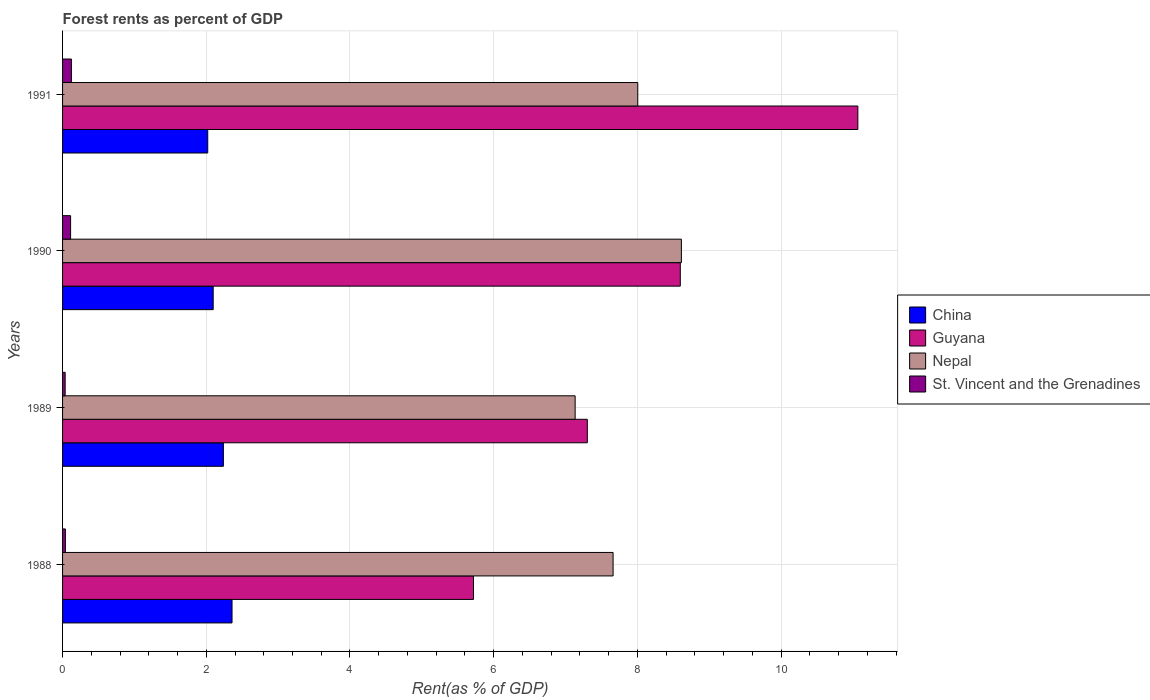How many groups of bars are there?
Offer a terse response. 4. Are the number of bars on each tick of the Y-axis equal?
Provide a succinct answer. Yes. How many bars are there on the 4th tick from the top?
Your response must be concise. 4. How many bars are there on the 4th tick from the bottom?
Your answer should be very brief. 4. What is the label of the 4th group of bars from the top?
Offer a terse response. 1988. In how many cases, is the number of bars for a given year not equal to the number of legend labels?
Offer a very short reply. 0. What is the forest rent in St. Vincent and the Grenadines in 1990?
Provide a short and direct response. 0.11. Across all years, what is the maximum forest rent in Guyana?
Offer a terse response. 11.07. Across all years, what is the minimum forest rent in St. Vincent and the Grenadines?
Your answer should be very brief. 0.04. In which year was the forest rent in China maximum?
Give a very brief answer. 1988. In which year was the forest rent in China minimum?
Provide a short and direct response. 1991. What is the total forest rent in Nepal in the graph?
Your answer should be very brief. 31.41. What is the difference between the forest rent in Guyana in 1989 and that in 1990?
Make the answer very short. -1.29. What is the difference between the forest rent in St. Vincent and the Grenadines in 1988 and the forest rent in China in 1989?
Provide a short and direct response. -2.2. What is the average forest rent in St. Vincent and the Grenadines per year?
Provide a succinct answer. 0.08. In the year 1988, what is the difference between the forest rent in China and forest rent in Guyana?
Provide a succinct answer. -3.36. What is the ratio of the forest rent in Nepal in 1989 to that in 1990?
Your response must be concise. 0.83. Is the forest rent in China in 1988 less than that in 1990?
Keep it short and to the point. No. Is the difference between the forest rent in China in 1990 and 1991 greater than the difference between the forest rent in Guyana in 1990 and 1991?
Provide a succinct answer. Yes. What is the difference between the highest and the second highest forest rent in Nepal?
Your response must be concise. 0.61. What is the difference between the highest and the lowest forest rent in St. Vincent and the Grenadines?
Your response must be concise. 0.09. Is the sum of the forest rent in Nepal in 1989 and 1991 greater than the maximum forest rent in China across all years?
Offer a terse response. Yes. What does the 2nd bar from the top in 1988 represents?
Give a very brief answer. Nepal. What does the 2nd bar from the bottom in 1988 represents?
Provide a short and direct response. Guyana. Is it the case that in every year, the sum of the forest rent in Nepal and forest rent in China is greater than the forest rent in St. Vincent and the Grenadines?
Provide a succinct answer. Yes. How many bars are there?
Provide a short and direct response. 16. Are the values on the major ticks of X-axis written in scientific E-notation?
Keep it short and to the point. No. Does the graph contain grids?
Make the answer very short. Yes. How many legend labels are there?
Ensure brevity in your answer.  4. How are the legend labels stacked?
Your answer should be very brief. Vertical. What is the title of the graph?
Your response must be concise. Forest rents as percent of GDP. What is the label or title of the X-axis?
Your answer should be very brief. Rent(as % of GDP). What is the Rent(as % of GDP) of China in 1988?
Your response must be concise. 2.36. What is the Rent(as % of GDP) in Guyana in 1988?
Your answer should be compact. 5.72. What is the Rent(as % of GDP) of Nepal in 1988?
Provide a succinct answer. 7.66. What is the Rent(as % of GDP) in St. Vincent and the Grenadines in 1988?
Give a very brief answer. 0.04. What is the Rent(as % of GDP) in China in 1989?
Keep it short and to the point. 2.24. What is the Rent(as % of GDP) in Guyana in 1989?
Ensure brevity in your answer.  7.3. What is the Rent(as % of GDP) in Nepal in 1989?
Provide a short and direct response. 7.13. What is the Rent(as % of GDP) in St. Vincent and the Grenadines in 1989?
Offer a terse response. 0.04. What is the Rent(as % of GDP) of China in 1990?
Offer a terse response. 2.1. What is the Rent(as % of GDP) in Guyana in 1990?
Your response must be concise. 8.6. What is the Rent(as % of GDP) of Nepal in 1990?
Your answer should be very brief. 8.61. What is the Rent(as % of GDP) of St. Vincent and the Grenadines in 1990?
Your answer should be compact. 0.11. What is the Rent(as % of GDP) of China in 1991?
Provide a succinct answer. 2.02. What is the Rent(as % of GDP) of Guyana in 1991?
Your response must be concise. 11.07. What is the Rent(as % of GDP) of Nepal in 1991?
Your response must be concise. 8.01. What is the Rent(as % of GDP) in St. Vincent and the Grenadines in 1991?
Keep it short and to the point. 0.12. Across all years, what is the maximum Rent(as % of GDP) of China?
Offer a terse response. 2.36. Across all years, what is the maximum Rent(as % of GDP) of Guyana?
Offer a terse response. 11.07. Across all years, what is the maximum Rent(as % of GDP) in Nepal?
Offer a very short reply. 8.61. Across all years, what is the maximum Rent(as % of GDP) of St. Vincent and the Grenadines?
Your response must be concise. 0.12. Across all years, what is the minimum Rent(as % of GDP) of China?
Provide a succinct answer. 2.02. Across all years, what is the minimum Rent(as % of GDP) of Guyana?
Offer a very short reply. 5.72. Across all years, what is the minimum Rent(as % of GDP) in Nepal?
Your answer should be compact. 7.13. Across all years, what is the minimum Rent(as % of GDP) of St. Vincent and the Grenadines?
Provide a succinct answer. 0.04. What is the total Rent(as % of GDP) in China in the graph?
Keep it short and to the point. 8.71. What is the total Rent(as % of GDP) of Guyana in the graph?
Your answer should be very brief. 32.69. What is the total Rent(as % of GDP) in Nepal in the graph?
Your response must be concise. 31.41. What is the total Rent(as % of GDP) in St. Vincent and the Grenadines in the graph?
Offer a very short reply. 0.31. What is the difference between the Rent(as % of GDP) of China in 1988 and that in 1989?
Your answer should be compact. 0.12. What is the difference between the Rent(as % of GDP) in Guyana in 1988 and that in 1989?
Keep it short and to the point. -1.58. What is the difference between the Rent(as % of GDP) of Nepal in 1988 and that in 1989?
Offer a very short reply. 0.53. What is the difference between the Rent(as % of GDP) of St. Vincent and the Grenadines in 1988 and that in 1989?
Provide a succinct answer. 0. What is the difference between the Rent(as % of GDP) in China in 1988 and that in 1990?
Provide a short and direct response. 0.26. What is the difference between the Rent(as % of GDP) of Guyana in 1988 and that in 1990?
Your answer should be compact. -2.88. What is the difference between the Rent(as % of GDP) of Nepal in 1988 and that in 1990?
Your response must be concise. -0.95. What is the difference between the Rent(as % of GDP) in St. Vincent and the Grenadines in 1988 and that in 1990?
Your answer should be very brief. -0.07. What is the difference between the Rent(as % of GDP) in China in 1988 and that in 1991?
Give a very brief answer. 0.34. What is the difference between the Rent(as % of GDP) of Guyana in 1988 and that in 1991?
Ensure brevity in your answer.  -5.35. What is the difference between the Rent(as % of GDP) in Nepal in 1988 and that in 1991?
Your answer should be very brief. -0.34. What is the difference between the Rent(as % of GDP) in St. Vincent and the Grenadines in 1988 and that in 1991?
Your response must be concise. -0.08. What is the difference between the Rent(as % of GDP) in China in 1989 and that in 1990?
Your answer should be very brief. 0.14. What is the difference between the Rent(as % of GDP) of Guyana in 1989 and that in 1990?
Your answer should be compact. -1.29. What is the difference between the Rent(as % of GDP) in Nepal in 1989 and that in 1990?
Your answer should be very brief. -1.48. What is the difference between the Rent(as % of GDP) of St. Vincent and the Grenadines in 1989 and that in 1990?
Provide a short and direct response. -0.08. What is the difference between the Rent(as % of GDP) of China in 1989 and that in 1991?
Provide a succinct answer. 0.22. What is the difference between the Rent(as % of GDP) in Guyana in 1989 and that in 1991?
Your answer should be very brief. -3.77. What is the difference between the Rent(as % of GDP) in Nepal in 1989 and that in 1991?
Make the answer very short. -0.87. What is the difference between the Rent(as % of GDP) of St. Vincent and the Grenadines in 1989 and that in 1991?
Offer a very short reply. -0.09. What is the difference between the Rent(as % of GDP) of China in 1990 and that in 1991?
Offer a very short reply. 0.08. What is the difference between the Rent(as % of GDP) in Guyana in 1990 and that in 1991?
Provide a succinct answer. -2.47. What is the difference between the Rent(as % of GDP) of Nepal in 1990 and that in 1991?
Provide a short and direct response. 0.61. What is the difference between the Rent(as % of GDP) of St. Vincent and the Grenadines in 1990 and that in 1991?
Offer a terse response. -0.01. What is the difference between the Rent(as % of GDP) of China in 1988 and the Rent(as % of GDP) of Guyana in 1989?
Make the answer very short. -4.94. What is the difference between the Rent(as % of GDP) in China in 1988 and the Rent(as % of GDP) in Nepal in 1989?
Make the answer very short. -4.78. What is the difference between the Rent(as % of GDP) in China in 1988 and the Rent(as % of GDP) in St. Vincent and the Grenadines in 1989?
Your answer should be very brief. 2.32. What is the difference between the Rent(as % of GDP) in Guyana in 1988 and the Rent(as % of GDP) in Nepal in 1989?
Offer a very short reply. -1.41. What is the difference between the Rent(as % of GDP) in Guyana in 1988 and the Rent(as % of GDP) in St. Vincent and the Grenadines in 1989?
Your response must be concise. 5.68. What is the difference between the Rent(as % of GDP) of Nepal in 1988 and the Rent(as % of GDP) of St. Vincent and the Grenadines in 1989?
Offer a very short reply. 7.63. What is the difference between the Rent(as % of GDP) of China in 1988 and the Rent(as % of GDP) of Guyana in 1990?
Your answer should be very brief. -6.24. What is the difference between the Rent(as % of GDP) in China in 1988 and the Rent(as % of GDP) in Nepal in 1990?
Your response must be concise. -6.25. What is the difference between the Rent(as % of GDP) of China in 1988 and the Rent(as % of GDP) of St. Vincent and the Grenadines in 1990?
Provide a short and direct response. 2.25. What is the difference between the Rent(as % of GDP) of Guyana in 1988 and the Rent(as % of GDP) of Nepal in 1990?
Make the answer very short. -2.89. What is the difference between the Rent(as % of GDP) in Guyana in 1988 and the Rent(as % of GDP) in St. Vincent and the Grenadines in 1990?
Provide a succinct answer. 5.61. What is the difference between the Rent(as % of GDP) of Nepal in 1988 and the Rent(as % of GDP) of St. Vincent and the Grenadines in 1990?
Give a very brief answer. 7.55. What is the difference between the Rent(as % of GDP) in China in 1988 and the Rent(as % of GDP) in Guyana in 1991?
Keep it short and to the point. -8.71. What is the difference between the Rent(as % of GDP) of China in 1988 and the Rent(as % of GDP) of Nepal in 1991?
Your answer should be compact. -5.65. What is the difference between the Rent(as % of GDP) of China in 1988 and the Rent(as % of GDP) of St. Vincent and the Grenadines in 1991?
Make the answer very short. 2.24. What is the difference between the Rent(as % of GDP) in Guyana in 1988 and the Rent(as % of GDP) in Nepal in 1991?
Give a very brief answer. -2.29. What is the difference between the Rent(as % of GDP) of Guyana in 1988 and the Rent(as % of GDP) of St. Vincent and the Grenadines in 1991?
Ensure brevity in your answer.  5.6. What is the difference between the Rent(as % of GDP) of Nepal in 1988 and the Rent(as % of GDP) of St. Vincent and the Grenadines in 1991?
Keep it short and to the point. 7.54. What is the difference between the Rent(as % of GDP) in China in 1989 and the Rent(as % of GDP) in Guyana in 1990?
Your answer should be very brief. -6.36. What is the difference between the Rent(as % of GDP) of China in 1989 and the Rent(as % of GDP) of Nepal in 1990?
Your response must be concise. -6.37. What is the difference between the Rent(as % of GDP) of China in 1989 and the Rent(as % of GDP) of St. Vincent and the Grenadines in 1990?
Keep it short and to the point. 2.13. What is the difference between the Rent(as % of GDP) in Guyana in 1989 and the Rent(as % of GDP) in Nepal in 1990?
Provide a short and direct response. -1.31. What is the difference between the Rent(as % of GDP) in Guyana in 1989 and the Rent(as % of GDP) in St. Vincent and the Grenadines in 1990?
Ensure brevity in your answer.  7.19. What is the difference between the Rent(as % of GDP) in Nepal in 1989 and the Rent(as % of GDP) in St. Vincent and the Grenadines in 1990?
Give a very brief answer. 7.02. What is the difference between the Rent(as % of GDP) of China in 1989 and the Rent(as % of GDP) of Guyana in 1991?
Provide a succinct answer. -8.83. What is the difference between the Rent(as % of GDP) of China in 1989 and the Rent(as % of GDP) of Nepal in 1991?
Your response must be concise. -5.77. What is the difference between the Rent(as % of GDP) of China in 1989 and the Rent(as % of GDP) of St. Vincent and the Grenadines in 1991?
Give a very brief answer. 2.12. What is the difference between the Rent(as % of GDP) of Guyana in 1989 and the Rent(as % of GDP) of Nepal in 1991?
Provide a short and direct response. -0.7. What is the difference between the Rent(as % of GDP) in Guyana in 1989 and the Rent(as % of GDP) in St. Vincent and the Grenadines in 1991?
Give a very brief answer. 7.18. What is the difference between the Rent(as % of GDP) in Nepal in 1989 and the Rent(as % of GDP) in St. Vincent and the Grenadines in 1991?
Your answer should be very brief. 7.01. What is the difference between the Rent(as % of GDP) of China in 1990 and the Rent(as % of GDP) of Guyana in 1991?
Give a very brief answer. -8.97. What is the difference between the Rent(as % of GDP) in China in 1990 and the Rent(as % of GDP) in Nepal in 1991?
Offer a very short reply. -5.91. What is the difference between the Rent(as % of GDP) in China in 1990 and the Rent(as % of GDP) in St. Vincent and the Grenadines in 1991?
Give a very brief answer. 1.97. What is the difference between the Rent(as % of GDP) in Guyana in 1990 and the Rent(as % of GDP) in Nepal in 1991?
Your response must be concise. 0.59. What is the difference between the Rent(as % of GDP) of Guyana in 1990 and the Rent(as % of GDP) of St. Vincent and the Grenadines in 1991?
Provide a succinct answer. 8.47. What is the difference between the Rent(as % of GDP) in Nepal in 1990 and the Rent(as % of GDP) in St. Vincent and the Grenadines in 1991?
Provide a succinct answer. 8.49. What is the average Rent(as % of GDP) in China per year?
Offer a very short reply. 2.18. What is the average Rent(as % of GDP) of Guyana per year?
Ensure brevity in your answer.  8.17. What is the average Rent(as % of GDP) of Nepal per year?
Keep it short and to the point. 7.85. What is the average Rent(as % of GDP) of St. Vincent and the Grenadines per year?
Your answer should be very brief. 0.08. In the year 1988, what is the difference between the Rent(as % of GDP) in China and Rent(as % of GDP) in Guyana?
Your response must be concise. -3.36. In the year 1988, what is the difference between the Rent(as % of GDP) in China and Rent(as % of GDP) in Nepal?
Make the answer very short. -5.3. In the year 1988, what is the difference between the Rent(as % of GDP) in China and Rent(as % of GDP) in St. Vincent and the Grenadines?
Offer a terse response. 2.32. In the year 1988, what is the difference between the Rent(as % of GDP) of Guyana and Rent(as % of GDP) of Nepal?
Offer a very short reply. -1.94. In the year 1988, what is the difference between the Rent(as % of GDP) of Guyana and Rent(as % of GDP) of St. Vincent and the Grenadines?
Provide a short and direct response. 5.68. In the year 1988, what is the difference between the Rent(as % of GDP) of Nepal and Rent(as % of GDP) of St. Vincent and the Grenadines?
Your answer should be very brief. 7.62. In the year 1989, what is the difference between the Rent(as % of GDP) of China and Rent(as % of GDP) of Guyana?
Provide a succinct answer. -5.07. In the year 1989, what is the difference between the Rent(as % of GDP) of China and Rent(as % of GDP) of Nepal?
Ensure brevity in your answer.  -4.9. In the year 1989, what is the difference between the Rent(as % of GDP) in China and Rent(as % of GDP) in St. Vincent and the Grenadines?
Offer a terse response. 2.2. In the year 1989, what is the difference between the Rent(as % of GDP) of Guyana and Rent(as % of GDP) of Nepal?
Make the answer very short. 0.17. In the year 1989, what is the difference between the Rent(as % of GDP) of Guyana and Rent(as % of GDP) of St. Vincent and the Grenadines?
Offer a very short reply. 7.27. In the year 1989, what is the difference between the Rent(as % of GDP) of Nepal and Rent(as % of GDP) of St. Vincent and the Grenadines?
Provide a succinct answer. 7.1. In the year 1990, what is the difference between the Rent(as % of GDP) in China and Rent(as % of GDP) in Guyana?
Your answer should be very brief. -6.5. In the year 1990, what is the difference between the Rent(as % of GDP) of China and Rent(as % of GDP) of Nepal?
Offer a very short reply. -6.52. In the year 1990, what is the difference between the Rent(as % of GDP) in China and Rent(as % of GDP) in St. Vincent and the Grenadines?
Your response must be concise. 1.98. In the year 1990, what is the difference between the Rent(as % of GDP) in Guyana and Rent(as % of GDP) in Nepal?
Give a very brief answer. -0.01. In the year 1990, what is the difference between the Rent(as % of GDP) of Guyana and Rent(as % of GDP) of St. Vincent and the Grenadines?
Your answer should be very brief. 8.49. In the year 1990, what is the difference between the Rent(as % of GDP) of Nepal and Rent(as % of GDP) of St. Vincent and the Grenadines?
Make the answer very short. 8.5. In the year 1991, what is the difference between the Rent(as % of GDP) in China and Rent(as % of GDP) in Guyana?
Your response must be concise. -9.05. In the year 1991, what is the difference between the Rent(as % of GDP) in China and Rent(as % of GDP) in Nepal?
Your response must be concise. -5.99. In the year 1991, what is the difference between the Rent(as % of GDP) in China and Rent(as % of GDP) in St. Vincent and the Grenadines?
Provide a short and direct response. 1.9. In the year 1991, what is the difference between the Rent(as % of GDP) of Guyana and Rent(as % of GDP) of Nepal?
Provide a short and direct response. 3.06. In the year 1991, what is the difference between the Rent(as % of GDP) in Guyana and Rent(as % of GDP) in St. Vincent and the Grenadines?
Your answer should be very brief. 10.95. In the year 1991, what is the difference between the Rent(as % of GDP) of Nepal and Rent(as % of GDP) of St. Vincent and the Grenadines?
Your answer should be very brief. 7.88. What is the ratio of the Rent(as % of GDP) in China in 1988 to that in 1989?
Your answer should be very brief. 1.05. What is the ratio of the Rent(as % of GDP) of Guyana in 1988 to that in 1989?
Ensure brevity in your answer.  0.78. What is the ratio of the Rent(as % of GDP) in Nepal in 1988 to that in 1989?
Make the answer very short. 1.07. What is the ratio of the Rent(as % of GDP) of St. Vincent and the Grenadines in 1988 to that in 1989?
Provide a succinct answer. 1.1. What is the ratio of the Rent(as % of GDP) in China in 1988 to that in 1990?
Your answer should be compact. 1.13. What is the ratio of the Rent(as % of GDP) of Guyana in 1988 to that in 1990?
Offer a terse response. 0.67. What is the ratio of the Rent(as % of GDP) of Nepal in 1988 to that in 1990?
Provide a succinct answer. 0.89. What is the ratio of the Rent(as % of GDP) in St. Vincent and the Grenadines in 1988 to that in 1990?
Ensure brevity in your answer.  0.35. What is the ratio of the Rent(as % of GDP) in China in 1988 to that in 1991?
Give a very brief answer. 1.17. What is the ratio of the Rent(as % of GDP) in Guyana in 1988 to that in 1991?
Offer a very short reply. 0.52. What is the ratio of the Rent(as % of GDP) in Nepal in 1988 to that in 1991?
Offer a very short reply. 0.96. What is the ratio of the Rent(as % of GDP) of St. Vincent and the Grenadines in 1988 to that in 1991?
Ensure brevity in your answer.  0.32. What is the ratio of the Rent(as % of GDP) of China in 1989 to that in 1990?
Your answer should be very brief. 1.07. What is the ratio of the Rent(as % of GDP) of Guyana in 1989 to that in 1990?
Offer a terse response. 0.85. What is the ratio of the Rent(as % of GDP) in Nepal in 1989 to that in 1990?
Your answer should be compact. 0.83. What is the ratio of the Rent(as % of GDP) of St. Vincent and the Grenadines in 1989 to that in 1990?
Offer a terse response. 0.32. What is the ratio of the Rent(as % of GDP) of China in 1989 to that in 1991?
Your response must be concise. 1.11. What is the ratio of the Rent(as % of GDP) of Guyana in 1989 to that in 1991?
Offer a very short reply. 0.66. What is the ratio of the Rent(as % of GDP) of Nepal in 1989 to that in 1991?
Make the answer very short. 0.89. What is the ratio of the Rent(as % of GDP) in St. Vincent and the Grenadines in 1989 to that in 1991?
Your answer should be very brief. 0.29. What is the ratio of the Rent(as % of GDP) in China in 1990 to that in 1991?
Ensure brevity in your answer.  1.04. What is the ratio of the Rent(as % of GDP) in Guyana in 1990 to that in 1991?
Offer a very short reply. 0.78. What is the ratio of the Rent(as % of GDP) in Nepal in 1990 to that in 1991?
Provide a succinct answer. 1.08. What is the ratio of the Rent(as % of GDP) in St. Vincent and the Grenadines in 1990 to that in 1991?
Your answer should be compact. 0.91. What is the difference between the highest and the second highest Rent(as % of GDP) of China?
Offer a terse response. 0.12. What is the difference between the highest and the second highest Rent(as % of GDP) in Guyana?
Your answer should be very brief. 2.47. What is the difference between the highest and the second highest Rent(as % of GDP) in Nepal?
Keep it short and to the point. 0.61. What is the difference between the highest and the second highest Rent(as % of GDP) of St. Vincent and the Grenadines?
Your answer should be compact. 0.01. What is the difference between the highest and the lowest Rent(as % of GDP) in China?
Your answer should be compact. 0.34. What is the difference between the highest and the lowest Rent(as % of GDP) in Guyana?
Offer a very short reply. 5.35. What is the difference between the highest and the lowest Rent(as % of GDP) of Nepal?
Keep it short and to the point. 1.48. What is the difference between the highest and the lowest Rent(as % of GDP) of St. Vincent and the Grenadines?
Keep it short and to the point. 0.09. 